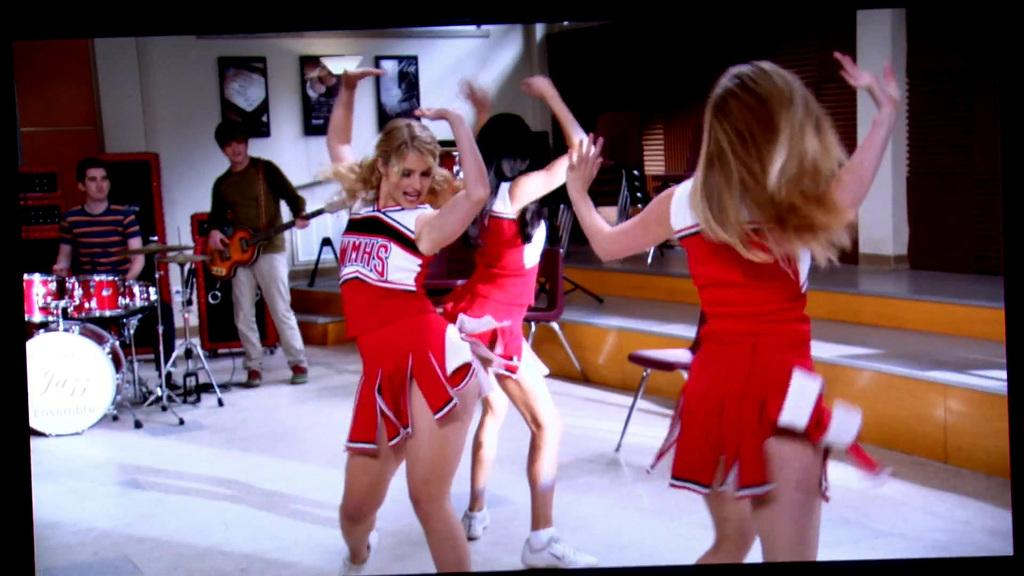Provide a one-sentence caption for the provided image. A cheerleader is wearing a red uniform that says "WMHS.". 